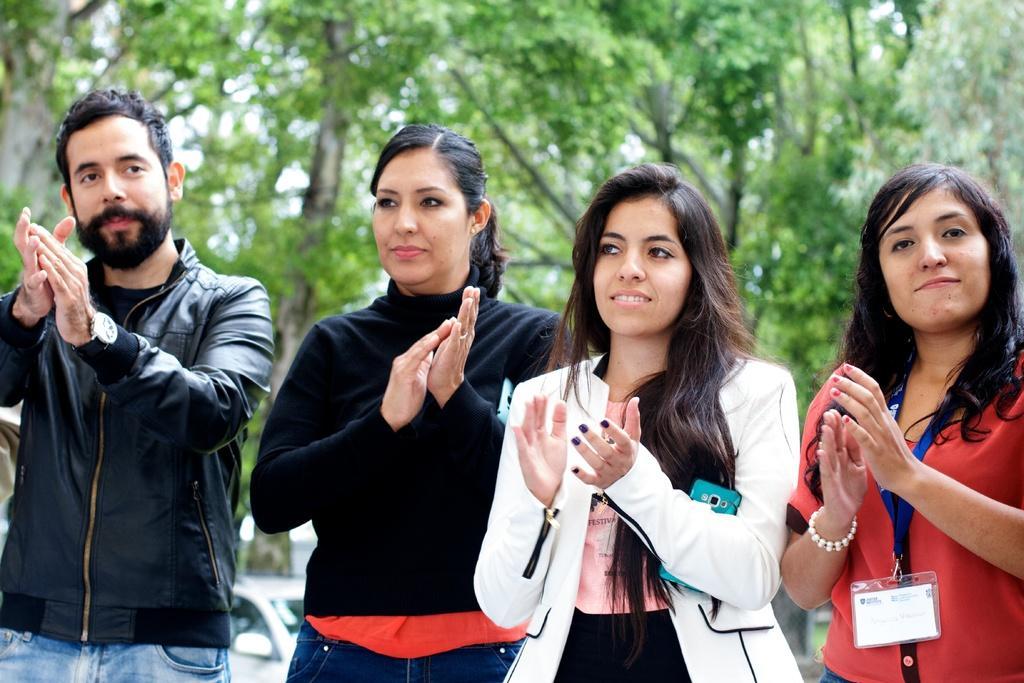Please provide a concise description of this image. To the left side of the image there is a man with black jacket is standing and clapping. Beside him there is a lady with black jacket is standing and clapping. Beside her to the right side there is a lady with white jacket is standing and holding the mobile and she is clapping. To the right corner of the image there is a lady with pink top, blue tag and an identity card is standing and clapping. Behind them to the top of the image there are trees and to the bottom of the image there is a car. 